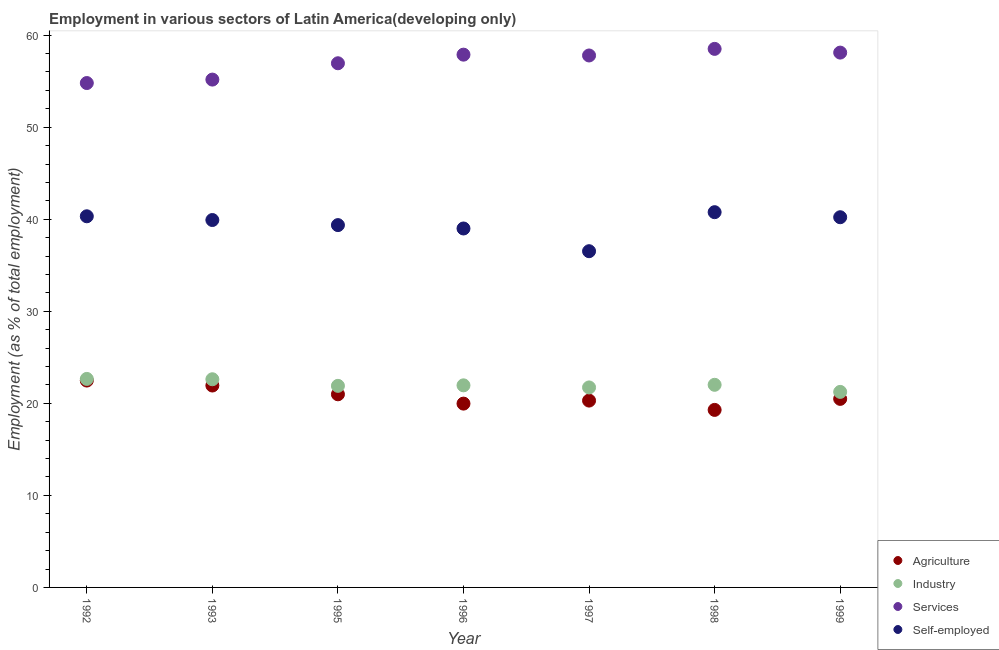Is the number of dotlines equal to the number of legend labels?
Make the answer very short. Yes. What is the percentage of self employed workers in 1995?
Keep it short and to the point. 39.36. Across all years, what is the maximum percentage of workers in services?
Keep it short and to the point. 58.51. Across all years, what is the minimum percentage of workers in industry?
Ensure brevity in your answer.  21.24. In which year was the percentage of workers in agriculture maximum?
Your answer should be compact. 1992. In which year was the percentage of workers in services minimum?
Your response must be concise. 1992. What is the total percentage of workers in industry in the graph?
Your answer should be very brief. 154.1. What is the difference between the percentage of workers in services in 1992 and that in 1996?
Make the answer very short. -3.08. What is the difference between the percentage of workers in industry in 1998 and the percentage of workers in agriculture in 1996?
Provide a succinct answer. 2.04. What is the average percentage of workers in industry per year?
Your response must be concise. 22.01. In the year 1993, what is the difference between the percentage of workers in services and percentage of workers in industry?
Your answer should be very brief. 32.56. In how many years, is the percentage of workers in agriculture greater than 40 %?
Give a very brief answer. 0. What is the ratio of the percentage of self employed workers in 1998 to that in 1999?
Offer a terse response. 1.01. Is the percentage of workers in industry in 1992 less than that in 1996?
Make the answer very short. No. Is the difference between the percentage of workers in industry in 1996 and 1997 greater than the difference between the percentage of workers in agriculture in 1996 and 1997?
Your answer should be compact. Yes. What is the difference between the highest and the second highest percentage of workers in agriculture?
Offer a terse response. 0.54. What is the difference between the highest and the lowest percentage of workers in agriculture?
Offer a terse response. 3.19. In how many years, is the percentage of workers in agriculture greater than the average percentage of workers in agriculture taken over all years?
Provide a short and direct response. 3. Is the sum of the percentage of workers in industry in 1992 and 1999 greater than the maximum percentage of workers in agriculture across all years?
Offer a terse response. Yes. Does the percentage of workers in industry monotonically increase over the years?
Your answer should be compact. No. Is the percentage of workers in agriculture strictly less than the percentage of self employed workers over the years?
Provide a short and direct response. Yes. How many years are there in the graph?
Provide a short and direct response. 7. What is the difference between two consecutive major ticks on the Y-axis?
Your answer should be very brief. 10. Are the values on the major ticks of Y-axis written in scientific E-notation?
Your answer should be compact. No. Does the graph contain any zero values?
Ensure brevity in your answer.  No. Where does the legend appear in the graph?
Your response must be concise. Bottom right. How are the legend labels stacked?
Your answer should be very brief. Vertical. What is the title of the graph?
Provide a short and direct response. Employment in various sectors of Latin America(developing only). What is the label or title of the Y-axis?
Ensure brevity in your answer.  Employment (as % of total employment). What is the Employment (as % of total employment) in Agriculture in 1992?
Offer a terse response. 22.47. What is the Employment (as % of total employment) in Industry in 1992?
Provide a short and direct response. 22.65. What is the Employment (as % of total employment) in Services in 1992?
Give a very brief answer. 54.8. What is the Employment (as % of total employment) of Self-employed in 1992?
Ensure brevity in your answer.  40.32. What is the Employment (as % of total employment) of Agriculture in 1993?
Make the answer very short. 21.94. What is the Employment (as % of total employment) of Industry in 1993?
Your answer should be compact. 22.61. What is the Employment (as % of total employment) of Services in 1993?
Ensure brevity in your answer.  55.17. What is the Employment (as % of total employment) of Self-employed in 1993?
Give a very brief answer. 39.91. What is the Employment (as % of total employment) in Agriculture in 1995?
Ensure brevity in your answer.  20.98. What is the Employment (as % of total employment) in Industry in 1995?
Your answer should be compact. 21.9. What is the Employment (as % of total employment) in Services in 1995?
Offer a terse response. 56.95. What is the Employment (as % of total employment) in Self-employed in 1995?
Your answer should be compact. 39.36. What is the Employment (as % of total employment) of Agriculture in 1996?
Offer a very short reply. 19.97. What is the Employment (as % of total employment) of Industry in 1996?
Keep it short and to the point. 21.95. What is the Employment (as % of total employment) of Services in 1996?
Make the answer very short. 57.88. What is the Employment (as % of total employment) in Self-employed in 1996?
Ensure brevity in your answer.  39. What is the Employment (as % of total employment) of Agriculture in 1997?
Your answer should be compact. 20.3. What is the Employment (as % of total employment) in Industry in 1997?
Offer a terse response. 21.73. What is the Employment (as % of total employment) of Services in 1997?
Your answer should be very brief. 57.79. What is the Employment (as % of total employment) in Self-employed in 1997?
Offer a terse response. 36.53. What is the Employment (as % of total employment) in Agriculture in 1998?
Your response must be concise. 19.29. What is the Employment (as % of total employment) of Industry in 1998?
Keep it short and to the point. 22.01. What is the Employment (as % of total employment) in Services in 1998?
Offer a very short reply. 58.51. What is the Employment (as % of total employment) in Self-employed in 1998?
Your answer should be very brief. 40.77. What is the Employment (as % of total employment) of Agriculture in 1999?
Provide a short and direct response. 20.48. What is the Employment (as % of total employment) of Industry in 1999?
Your response must be concise. 21.24. What is the Employment (as % of total employment) in Services in 1999?
Offer a very short reply. 58.1. What is the Employment (as % of total employment) in Self-employed in 1999?
Your response must be concise. 40.22. Across all years, what is the maximum Employment (as % of total employment) in Agriculture?
Provide a succinct answer. 22.47. Across all years, what is the maximum Employment (as % of total employment) in Industry?
Your response must be concise. 22.65. Across all years, what is the maximum Employment (as % of total employment) of Services?
Offer a terse response. 58.51. Across all years, what is the maximum Employment (as % of total employment) in Self-employed?
Ensure brevity in your answer.  40.77. Across all years, what is the minimum Employment (as % of total employment) in Agriculture?
Offer a very short reply. 19.29. Across all years, what is the minimum Employment (as % of total employment) of Industry?
Keep it short and to the point. 21.24. Across all years, what is the minimum Employment (as % of total employment) of Services?
Your answer should be very brief. 54.8. Across all years, what is the minimum Employment (as % of total employment) of Self-employed?
Offer a very short reply. 36.53. What is the total Employment (as % of total employment) of Agriculture in the graph?
Your response must be concise. 145.43. What is the total Employment (as % of total employment) in Industry in the graph?
Offer a terse response. 154.1. What is the total Employment (as % of total employment) in Services in the graph?
Provide a succinct answer. 399.19. What is the total Employment (as % of total employment) of Self-employed in the graph?
Offer a very short reply. 276.11. What is the difference between the Employment (as % of total employment) in Agriculture in 1992 and that in 1993?
Provide a succinct answer. 0.54. What is the difference between the Employment (as % of total employment) of Industry in 1992 and that in 1993?
Give a very brief answer. 0.04. What is the difference between the Employment (as % of total employment) of Services in 1992 and that in 1993?
Give a very brief answer. -0.38. What is the difference between the Employment (as % of total employment) of Self-employed in 1992 and that in 1993?
Provide a short and direct response. 0.41. What is the difference between the Employment (as % of total employment) of Agriculture in 1992 and that in 1995?
Offer a very short reply. 1.49. What is the difference between the Employment (as % of total employment) in Industry in 1992 and that in 1995?
Offer a terse response. 0.75. What is the difference between the Employment (as % of total employment) in Services in 1992 and that in 1995?
Keep it short and to the point. -2.15. What is the difference between the Employment (as % of total employment) in Self-employed in 1992 and that in 1995?
Ensure brevity in your answer.  0.96. What is the difference between the Employment (as % of total employment) in Agriculture in 1992 and that in 1996?
Make the answer very short. 2.5. What is the difference between the Employment (as % of total employment) in Industry in 1992 and that in 1996?
Provide a succinct answer. 0.7. What is the difference between the Employment (as % of total employment) of Services in 1992 and that in 1996?
Your answer should be very brief. -3.08. What is the difference between the Employment (as % of total employment) in Self-employed in 1992 and that in 1996?
Provide a short and direct response. 1.33. What is the difference between the Employment (as % of total employment) in Agriculture in 1992 and that in 1997?
Your answer should be very brief. 2.18. What is the difference between the Employment (as % of total employment) of Industry in 1992 and that in 1997?
Provide a short and direct response. 0.93. What is the difference between the Employment (as % of total employment) in Services in 1992 and that in 1997?
Your answer should be compact. -2.99. What is the difference between the Employment (as % of total employment) of Self-employed in 1992 and that in 1997?
Ensure brevity in your answer.  3.79. What is the difference between the Employment (as % of total employment) in Agriculture in 1992 and that in 1998?
Provide a short and direct response. 3.19. What is the difference between the Employment (as % of total employment) of Industry in 1992 and that in 1998?
Provide a short and direct response. 0.64. What is the difference between the Employment (as % of total employment) of Services in 1992 and that in 1998?
Your answer should be compact. -3.71. What is the difference between the Employment (as % of total employment) of Self-employed in 1992 and that in 1998?
Ensure brevity in your answer.  -0.45. What is the difference between the Employment (as % of total employment) of Agriculture in 1992 and that in 1999?
Give a very brief answer. 1.99. What is the difference between the Employment (as % of total employment) in Industry in 1992 and that in 1999?
Make the answer very short. 1.41. What is the difference between the Employment (as % of total employment) in Services in 1992 and that in 1999?
Your answer should be very brief. -3.31. What is the difference between the Employment (as % of total employment) in Self-employed in 1992 and that in 1999?
Your answer should be compact. 0.1. What is the difference between the Employment (as % of total employment) of Agriculture in 1993 and that in 1995?
Keep it short and to the point. 0.95. What is the difference between the Employment (as % of total employment) of Industry in 1993 and that in 1995?
Provide a short and direct response. 0.72. What is the difference between the Employment (as % of total employment) in Services in 1993 and that in 1995?
Keep it short and to the point. -1.77. What is the difference between the Employment (as % of total employment) of Self-employed in 1993 and that in 1995?
Offer a very short reply. 0.55. What is the difference between the Employment (as % of total employment) in Agriculture in 1993 and that in 1996?
Your answer should be very brief. 1.97. What is the difference between the Employment (as % of total employment) of Industry in 1993 and that in 1996?
Your response must be concise. 0.66. What is the difference between the Employment (as % of total employment) in Services in 1993 and that in 1996?
Make the answer very short. -2.71. What is the difference between the Employment (as % of total employment) of Self-employed in 1993 and that in 1996?
Your answer should be compact. 0.92. What is the difference between the Employment (as % of total employment) in Agriculture in 1993 and that in 1997?
Your answer should be compact. 1.64. What is the difference between the Employment (as % of total employment) of Industry in 1993 and that in 1997?
Keep it short and to the point. 0.89. What is the difference between the Employment (as % of total employment) in Services in 1993 and that in 1997?
Your response must be concise. -2.62. What is the difference between the Employment (as % of total employment) in Self-employed in 1993 and that in 1997?
Give a very brief answer. 3.39. What is the difference between the Employment (as % of total employment) in Agriculture in 1993 and that in 1998?
Offer a terse response. 2.65. What is the difference between the Employment (as % of total employment) in Industry in 1993 and that in 1998?
Your answer should be very brief. 0.6. What is the difference between the Employment (as % of total employment) of Services in 1993 and that in 1998?
Your answer should be very brief. -3.34. What is the difference between the Employment (as % of total employment) of Self-employed in 1993 and that in 1998?
Provide a succinct answer. -0.85. What is the difference between the Employment (as % of total employment) in Agriculture in 1993 and that in 1999?
Make the answer very short. 1.45. What is the difference between the Employment (as % of total employment) in Industry in 1993 and that in 1999?
Your response must be concise. 1.37. What is the difference between the Employment (as % of total employment) in Services in 1993 and that in 1999?
Your answer should be compact. -2.93. What is the difference between the Employment (as % of total employment) of Self-employed in 1993 and that in 1999?
Your response must be concise. -0.3. What is the difference between the Employment (as % of total employment) in Agriculture in 1995 and that in 1996?
Your answer should be very brief. 1.01. What is the difference between the Employment (as % of total employment) in Industry in 1995 and that in 1996?
Ensure brevity in your answer.  -0.06. What is the difference between the Employment (as % of total employment) of Services in 1995 and that in 1996?
Offer a very short reply. -0.94. What is the difference between the Employment (as % of total employment) in Self-employed in 1995 and that in 1996?
Provide a short and direct response. 0.37. What is the difference between the Employment (as % of total employment) in Agriculture in 1995 and that in 1997?
Offer a terse response. 0.68. What is the difference between the Employment (as % of total employment) of Industry in 1995 and that in 1997?
Make the answer very short. 0.17. What is the difference between the Employment (as % of total employment) in Services in 1995 and that in 1997?
Your response must be concise. -0.85. What is the difference between the Employment (as % of total employment) of Self-employed in 1995 and that in 1997?
Offer a very short reply. 2.84. What is the difference between the Employment (as % of total employment) in Agriculture in 1995 and that in 1998?
Provide a succinct answer. 1.69. What is the difference between the Employment (as % of total employment) of Industry in 1995 and that in 1998?
Keep it short and to the point. -0.11. What is the difference between the Employment (as % of total employment) of Services in 1995 and that in 1998?
Your response must be concise. -1.56. What is the difference between the Employment (as % of total employment) of Self-employed in 1995 and that in 1998?
Your response must be concise. -1.4. What is the difference between the Employment (as % of total employment) of Agriculture in 1995 and that in 1999?
Your answer should be very brief. 0.5. What is the difference between the Employment (as % of total employment) of Industry in 1995 and that in 1999?
Provide a succinct answer. 0.66. What is the difference between the Employment (as % of total employment) of Services in 1995 and that in 1999?
Keep it short and to the point. -1.16. What is the difference between the Employment (as % of total employment) in Self-employed in 1995 and that in 1999?
Make the answer very short. -0.86. What is the difference between the Employment (as % of total employment) of Agriculture in 1996 and that in 1997?
Your answer should be very brief. -0.33. What is the difference between the Employment (as % of total employment) in Industry in 1996 and that in 1997?
Your answer should be very brief. 0.23. What is the difference between the Employment (as % of total employment) of Services in 1996 and that in 1997?
Provide a short and direct response. 0.09. What is the difference between the Employment (as % of total employment) in Self-employed in 1996 and that in 1997?
Make the answer very short. 2.47. What is the difference between the Employment (as % of total employment) in Agriculture in 1996 and that in 1998?
Your answer should be very brief. 0.68. What is the difference between the Employment (as % of total employment) in Industry in 1996 and that in 1998?
Your answer should be compact. -0.06. What is the difference between the Employment (as % of total employment) of Services in 1996 and that in 1998?
Provide a succinct answer. -0.63. What is the difference between the Employment (as % of total employment) in Self-employed in 1996 and that in 1998?
Offer a very short reply. -1.77. What is the difference between the Employment (as % of total employment) of Agriculture in 1996 and that in 1999?
Ensure brevity in your answer.  -0.51. What is the difference between the Employment (as % of total employment) of Industry in 1996 and that in 1999?
Provide a short and direct response. 0.71. What is the difference between the Employment (as % of total employment) in Services in 1996 and that in 1999?
Offer a terse response. -0.22. What is the difference between the Employment (as % of total employment) of Self-employed in 1996 and that in 1999?
Provide a succinct answer. -1.22. What is the difference between the Employment (as % of total employment) in Agriculture in 1997 and that in 1998?
Your answer should be compact. 1.01. What is the difference between the Employment (as % of total employment) in Industry in 1997 and that in 1998?
Provide a short and direct response. -0.29. What is the difference between the Employment (as % of total employment) of Services in 1997 and that in 1998?
Your response must be concise. -0.72. What is the difference between the Employment (as % of total employment) in Self-employed in 1997 and that in 1998?
Provide a short and direct response. -4.24. What is the difference between the Employment (as % of total employment) of Agriculture in 1997 and that in 1999?
Offer a very short reply. -0.19. What is the difference between the Employment (as % of total employment) of Industry in 1997 and that in 1999?
Keep it short and to the point. 0.48. What is the difference between the Employment (as % of total employment) of Services in 1997 and that in 1999?
Your answer should be compact. -0.31. What is the difference between the Employment (as % of total employment) in Self-employed in 1997 and that in 1999?
Ensure brevity in your answer.  -3.69. What is the difference between the Employment (as % of total employment) of Agriculture in 1998 and that in 1999?
Provide a short and direct response. -1.2. What is the difference between the Employment (as % of total employment) in Industry in 1998 and that in 1999?
Ensure brevity in your answer.  0.77. What is the difference between the Employment (as % of total employment) in Services in 1998 and that in 1999?
Keep it short and to the point. 0.4. What is the difference between the Employment (as % of total employment) of Self-employed in 1998 and that in 1999?
Give a very brief answer. 0.55. What is the difference between the Employment (as % of total employment) of Agriculture in 1992 and the Employment (as % of total employment) of Industry in 1993?
Your answer should be very brief. -0.14. What is the difference between the Employment (as % of total employment) in Agriculture in 1992 and the Employment (as % of total employment) in Services in 1993?
Provide a succinct answer. -32.7. What is the difference between the Employment (as % of total employment) in Agriculture in 1992 and the Employment (as % of total employment) in Self-employed in 1993?
Your response must be concise. -17.44. What is the difference between the Employment (as % of total employment) of Industry in 1992 and the Employment (as % of total employment) of Services in 1993?
Ensure brevity in your answer.  -32.52. What is the difference between the Employment (as % of total employment) of Industry in 1992 and the Employment (as % of total employment) of Self-employed in 1993?
Ensure brevity in your answer.  -17.26. What is the difference between the Employment (as % of total employment) in Services in 1992 and the Employment (as % of total employment) in Self-employed in 1993?
Your answer should be compact. 14.88. What is the difference between the Employment (as % of total employment) in Agriculture in 1992 and the Employment (as % of total employment) in Industry in 1995?
Make the answer very short. 0.57. What is the difference between the Employment (as % of total employment) of Agriculture in 1992 and the Employment (as % of total employment) of Services in 1995?
Your response must be concise. -34.47. What is the difference between the Employment (as % of total employment) in Agriculture in 1992 and the Employment (as % of total employment) in Self-employed in 1995?
Give a very brief answer. -16.89. What is the difference between the Employment (as % of total employment) in Industry in 1992 and the Employment (as % of total employment) in Services in 1995?
Offer a very short reply. -34.29. What is the difference between the Employment (as % of total employment) in Industry in 1992 and the Employment (as % of total employment) in Self-employed in 1995?
Offer a terse response. -16.71. What is the difference between the Employment (as % of total employment) in Services in 1992 and the Employment (as % of total employment) in Self-employed in 1995?
Provide a succinct answer. 15.43. What is the difference between the Employment (as % of total employment) in Agriculture in 1992 and the Employment (as % of total employment) in Industry in 1996?
Give a very brief answer. 0.52. What is the difference between the Employment (as % of total employment) in Agriculture in 1992 and the Employment (as % of total employment) in Services in 1996?
Keep it short and to the point. -35.41. What is the difference between the Employment (as % of total employment) in Agriculture in 1992 and the Employment (as % of total employment) in Self-employed in 1996?
Offer a very short reply. -16.52. What is the difference between the Employment (as % of total employment) of Industry in 1992 and the Employment (as % of total employment) of Services in 1996?
Provide a succinct answer. -35.23. What is the difference between the Employment (as % of total employment) of Industry in 1992 and the Employment (as % of total employment) of Self-employed in 1996?
Ensure brevity in your answer.  -16.34. What is the difference between the Employment (as % of total employment) in Services in 1992 and the Employment (as % of total employment) in Self-employed in 1996?
Give a very brief answer. 15.8. What is the difference between the Employment (as % of total employment) of Agriculture in 1992 and the Employment (as % of total employment) of Industry in 1997?
Give a very brief answer. 0.75. What is the difference between the Employment (as % of total employment) in Agriculture in 1992 and the Employment (as % of total employment) in Services in 1997?
Your response must be concise. -35.32. What is the difference between the Employment (as % of total employment) of Agriculture in 1992 and the Employment (as % of total employment) of Self-employed in 1997?
Your answer should be very brief. -14.05. What is the difference between the Employment (as % of total employment) of Industry in 1992 and the Employment (as % of total employment) of Services in 1997?
Give a very brief answer. -35.14. What is the difference between the Employment (as % of total employment) of Industry in 1992 and the Employment (as % of total employment) of Self-employed in 1997?
Your answer should be compact. -13.88. What is the difference between the Employment (as % of total employment) of Services in 1992 and the Employment (as % of total employment) of Self-employed in 1997?
Your response must be concise. 18.27. What is the difference between the Employment (as % of total employment) of Agriculture in 1992 and the Employment (as % of total employment) of Industry in 1998?
Give a very brief answer. 0.46. What is the difference between the Employment (as % of total employment) of Agriculture in 1992 and the Employment (as % of total employment) of Services in 1998?
Ensure brevity in your answer.  -36.03. What is the difference between the Employment (as % of total employment) of Agriculture in 1992 and the Employment (as % of total employment) of Self-employed in 1998?
Make the answer very short. -18.29. What is the difference between the Employment (as % of total employment) of Industry in 1992 and the Employment (as % of total employment) of Services in 1998?
Give a very brief answer. -35.86. What is the difference between the Employment (as % of total employment) of Industry in 1992 and the Employment (as % of total employment) of Self-employed in 1998?
Give a very brief answer. -18.11. What is the difference between the Employment (as % of total employment) of Services in 1992 and the Employment (as % of total employment) of Self-employed in 1998?
Make the answer very short. 14.03. What is the difference between the Employment (as % of total employment) in Agriculture in 1992 and the Employment (as % of total employment) in Industry in 1999?
Keep it short and to the point. 1.23. What is the difference between the Employment (as % of total employment) in Agriculture in 1992 and the Employment (as % of total employment) in Services in 1999?
Provide a succinct answer. -35.63. What is the difference between the Employment (as % of total employment) in Agriculture in 1992 and the Employment (as % of total employment) in Self-employed in 1999?
Make the answer very short. -17.74. What is the difference between the Employment (as % of total employment) in Industry in 1992 and the Employment (as % of total employment) in Services in 1999?
Provide a short and direct response. -35.45. What is the difference between the Employment (as % of total employment) in Industry in 1992 and the Employment (as % of total employment) in Self-employed in 1999?
Make the answer very short. -17.57. What is the difference between the Employment (as % of total employment) of Services in 1992 and the Employment (as % of total employment) of Self-employed in 1999?
Offer a terse response. 14.58. What is the difference between the Employment (as % of total employment) of Agriculture in 1993 and the Employment (as % of total employment) of Industry in 1995?
Offer a terse response. 0.04. What is the difference between the Employment (as % of total employment) in Agriculture in 1993 and the Employment (as % of total employment) in Services in 1995?
Give a very brief answer. -35.01. What is the difference between the Employment (as % of total employment) of Agriculture in 1993 and the Employment (as % of total employment) of Self-employed in 1995?
Provide a short and direct response. -17.43. What is the difference between the Employment (as % of total employment) of Industry in 1993 and the Employment (as % of total employment) of Services in 1995?
Keep it short and to the point. -34.33. What is the difference between the Employment (as % of total employment) of Industry in 1993 and the Employment (as % of total employment) of Self-employed in 1995?
Give a very brief answer. -16.75. What is the difference between the Employment (as % of total employment) in Services in 1993 and the Employment (as % of total employment) in Self-employed in 1995?
Keep it short and to the point. 15.81. What is the difference between the Employment (as % of total employment) in Agriculture in 1993 and the Employment (as % of total employment) in Industry in 1996?
Provide a short and direct response. -0.02. What is the difference between the Employment (as % of total employment) of Agriculture in 1993 and the Employment (as % of total employment) of Services in 1996?
Provide a short and direct response. -35.95. What is the difference between the Employment (as % of total employment) of Agriculture in 1993 and the Employment (as % of total employment) of Self-employed in 1996?
Offer a terse response. -17.06. What is the difference between the Employment (as % of total employment) of Industry in 1993 and the Employment (as % of total employment) of Services in 1996?
Keep it short and to the point. -35.27. What is the difference between the Employment (as % of total employment) of Industry in 1993 and the Employment (as % of total employment) of Self-employed in 1996?
Your response must be concise. -16.38. What is the difference between the Employment (as % of total employment) of Services in 1993 and the Employment (as % of total employment) of Self-employed in 1996?
Your answer should be compact. 16.18. What is the difference between the Employment (as % of total employment) in Agriculture in 1993 and the Employment (as % of total employment) in Industry in 1997?
Provide a succinct answer. 0.21. What is the difference between the Employment (as % of total employment) in Agriculture in 1993 and the Employment (as % of total employment) in Services in 1997?
Ensure brevity in your answer.  -35.86. What is the difference between the Employment (as % of total employment) in Agriculture in 1993 and the Employment (as % of total employment) in Self-employed in 1997?
Your answer should be compact. -14.59. What is the difference between the Employment (as % of total employment) of Industry in 1993 and the Employment (as % of total employment) of Services in 1997?
Offer a very short reply. -35.18. What is the difference between the Employment (as % of total employment) of Industry in 1993 and the Employment (as % of total employment) of Self-employed in 1997?
Provide a succinct answer. -13.91. What is the difference between the Employment (as % of total employment) in Services in 1993 and the Employment (as % of total employment) in Self-employed in 1997?
Offer a very short reply. 18.64. What is the difference between the Employment (as % of total employment) in Agriculture in 1993 and the Employment (as % of total employment) in Industry in 1998?
Provide a short and direct response. -0.08. What is the difference between the Employment (as % of total employment) in Agriculture in 1993 and the Employment (as % of total employment) in Services in 1998?
Give a very brief answer. -36.57. What is the difference between the Employment (as % of total employment) in Agriculture in 1993 and the Employment (as % of total employment) in Self-employed in 1998?
Your answer should be compact. -18.83. What is the difference between the Employment (as % of total employment) of Industry in 1993 and the Employment (as % of total employment) of Services in 1998?
Offer a very short reply. -35.89. What is the difference between the Employment (as % of total employment) in Industry in 1993 and the Employment (as % of total employment) in Self-employed in 1998?
Your answer should be compact. -18.15. What is the difference between the Employment (as % of total employment) of Services in 1993 and the Employment (as % of total employment) of Self-employed in 1998?
Ensure brevity in your answer.  14.4. What is the difference between the Employment (as % of total employment) in Agriculture in 1993 and the Employment (as % of total employment) in Industry in 1999?
Offer a very short reply. 0.69. What is the difference between the Employment (as % of total employment) in Agriculture in 1993 and the Employment (as % of total employment) in Services in 1999?
Provide a short and direct response. -36.17. What is the difference between the Employment (as % of total employment) in Agriculture in 1993 and the Employment (as % of total employment) in Self-employed in 1999?
Give a very brief answer. -18.28. What is the difference between the Employment (as % of total employment) in Industry in 1993 and the Employment (as % of total employment) in Services in 1999?
Provide a succinct answer. -35.49. What is the difference between the Employment (as % of total employment) in Industry in 1993 and the Employment (as % of total employment) in Self-employed in 1999?
Provide a short and direct response. -17.6. What is the difference between the Employment (as % of total employment) of Services in 1993 and the Employment (as % of total employment) of Self-employed in 1999?
Provide a short and direct response. 14.95. What is the difference between the Employment (as % of total employment) in Agriculture in 1995 and the Employment (as % of total employment) in Industry in 1996?
Keep it short and to the point. -0.97. What is the difference between the Employment (as % of total employment) in Agriculture in 1995 and the Employment (as % of total employment) in Services in 1996?
Ensure brevity in your answer.  -36.9. What is the difference between the Employment (as % of total employment) in Agriculture in 1995 and the Employment (as % of total employment) in Self-employed in 1996?
Ensure brevity in your answer.  -18.01. What is the difference between the Employment (as % of total employment) of Industry in 1995 and the Employment (as % of total employment) of Services in 1996?
Offer a terse response. -35.98. What is the difference between the Employment (as % of total employment) in Industry in 1995 and the Employment (as % of total employment) in Self-employed in 1996?
Provide a short and direct response. -17.1. What is the difference between the Employment (as % of total employment) of Services in 1995 and the Employment (as % of total employment) of Self-employed in 1996?
Ensure brevity in your answer.  17.95. What is the difference between the Employment (as % of total employment) in Agriculture in 1995 and the Employment (as % of total employment) in Industry in 1997?
Your answer should be very brief. -0.75. What is the difference between the Employment (as % of total employment) in Agriculture in 1995 and the Employment (as % of total employment) in Services in 1997?
Keep it short and to the point. -36.81. What is the difference between the Employment (as % of total employment) in Agriculture in 1995 and the Employment (as % of total employment) in Self-employed in 1997?
Your answer should be very brief. -15.55. What is the difference between the Employment (as % of total employment) in Industry in 1995 and the Employment (as % of total employment) in Services in 1997?
Keep it short and to the point. -35.89. What is the difference between the Employment (as % of total employment) in Industry in 1995 and the Employment (as % of total employment) in Self-employed in 1997?
Provide a short and direct response. -14.63. What is the difference between the Employment (as % of total employment) of Services in 1995 and the Employment (as % of total employment) of Self-employed in 1997?
Your answer should be very brief. 20.42. What is the difference between the Employment (as % of total employment) in Agriculture in 1995 and the Employment (as % of total employment) in Industry in 1998?
Provide a succinct answer. -1.03. What is the difference between the Employment (as % of total employment) of Agriculture in 1995 and the Employment (as % of total employment) of Services in 1998?
Ensure brevity in your answer.  -37.53. What is the difference between the Employment (as % of total employment) of Agriculture in 1995 and the Employment (as % of total employment) of Self-employed in 1998?
Your response must be concise. -19.79. What is the difference between the Employment (as % of total employment) in Industry in 1995 and the Employment (as % of total employment) in Services in 1998?
Give a very brief answer. -36.61. What is the difference between the Employment (as % of total employment) of Industry in 1995 and the Employment (as % of total employment) of Self-employed in 1998?
Offer a terse response. -18.87. What is the difference between the Employment (as % of total employment) in Services in 1995 and the Employment (as % of total employment) in Self-employed in 1998?
Your answer should be compact. 16.18. What is the difference between the Employment (as % of total employment) in Agriculture in 1995 and the Employment (as % of total employment) in Industry in 1999?
Ensure brevity in your answer.  -0.26. What is the difference between the Employment (as % of total employment) of Agriculture in 1995 and the Employment (as % of total employment) of Services in 1999?
Give a very brief answer. -37.12. What is the difference between the Employment (as % of total employment) of Agriculture in 1995 and the Employment (as % of total employment) of Self-employed in 1999?
Provide a short and direct response. -19.24. What is the difference between the Employment (as % of total employment) of Industry in 1995 and the Employment (as % of total employment) of Services in 1999?
Ensure brevity in your answer.  -36.2. What is the difference between the Employment (as % of total employment) of Industry in 1995 and the Employment (as % of total employment) of Self-employed in 1999?
Offer a very short reply. -18.32. What is the difference between the Employment (as % of total employment) of Services in 1995 and the Employment (as % of total employment) of Self-employed in 1999?
Ensure brevity in your answer.  16.73. What is the difference between the Employment (as % of total employment) of Agriculture in 1996 and the Employment (as % of total employment) of Industry in 1997?
Your answer should be very brief. -1.76. What is the difference between the Employment (as % of total employment) of Agriculture in 1996 and the Employment (as % of total employment) of Services in 1997?
Your answer should be compact. -37.82. What is the difference between the Employment (as % of total employment) in Agriculture in 1996 and the Employment (as % of total employment) in Self-employed in 1997?
Make the answer very short. -16.56. What is the difference between the Employment (as % of total employment) in Industry in 1996 and the Employment (as % of total employment) in Services in 1997?
Your answer should be compact. -35.84. What is the difference between the Employment (as % of total employment) in Industry in 1996 and the Employment (as % of total employment) in Self-employed in 1997?
Your answer should be compact. -14.57. What is the difference between the Employment (as % of total employment) in Services in 1996 and the Employment (as % of total employment) in Self-employed in 1997?
Ensure brevity in your answer.  21.35. What is the difference between the Employment (as % of total employment) of Agriculture in 1996 and the Employment (as % of total employment) of Industry in 1998?
Ensure brevity in your answer.  -2.04. What is the difference between the Employment (as % of total employment) in Agriculture in 1996 and the Employment (as % of total employment) in Services in 1998?
Provide a succinct answer. -38.54. What is the difference between the Employment (as % of total employment) of Agriculture in 1996 and the Employment (as % of total employment) of Self-employed in 1998?
Your answer should be very brief. -20.8. What is the difference between the Employment (as % of total employment) of Industry in 1996 and the Employment (as % of total employment) of Services in 1998?
Provide a short and direct response. -36.55. What is the difference between the Employment (as % of total employment) in Industry in 1996 and the Employment (as % of total employment) in Self-employed in 1998?
Keep it short and to the point. -18.81. What is the difference between the Employment (as % of total employment) of Services in 1996 and the Employment (as % of total employment) of Self-employed in 1998?
Your response must be concise. 17.11. What is the difference between the Employment (as % of total employment) of Agriculture in 1996 and the Employment (as % of total employment) of Industry in 1999?
Give a very brief answer. -1.27. What is the difference between the Employment (as % of total employment) in Agriculture in 1996 and the Employment (as % of total employment) in Services in 1999?
Provide a succinct answer. -38.13. What is the difference between the Employment (as % of total employment) of Agriculture in 1996 and the Employment (as % of total employment) of Self-employed in 1999?
Your answer should be very brief. -20.25. What is the difference between the Employment (as % of total employment) in Industry in 1996 and the Employment (as % of total employment) in Services in 1999?
Your answer should be very brief. -36.15. What is the difference between the Employment (as % of total employment) of Industry in 1996 and the Employment (as % of total employment) of Self-employed in 1999?
Make the answer very short. -18.26. What is the difference between the Employment (as % of total employment) of Services in 1996 and the Employment (as % of total employment) of Self-employed in 1999?
Provide a succinct answer. 17.66. What is the difference between the Employment (as % of total employment) in Agriculture in 1997 and the Employment (as % of total employment) in Industry in 1998?
Keep it short and to the point. -1.71. What is the difference between the Employment (as % of total employment) in Agriculture in 1997 and the Employment (as % of total employment) in Services in 1998?
Ensure brevity in your answer.  -38.21. What is the difference between the Employment (as % of total employment) in Agriculture in 1997 and the Employment (as % of total employment) in Self-employed in 1998?
Give a very brief answer. -20.47. What is the difference between the Employment (as % of total employment) in Industry in 1997 and the Employment (as % of total employment) in Services in 1998?
Make the answer very short. -36.78. What is the difference between the Employment (as % of total employment) of Industry in 1997 and the Employment (as % of total employment) of Self-employed in 1998?
Offer a terse response. -19.04. What is the difference between the Employment (as % of total employment) of Services in 1997 and the Employment (as % of total employment) of Self-employed in 1998?
Offer a very short reply. 17.02. What is the difference between the Employment (as % of total employment) of Agriculture in 1997 and the Employment (as % of total employment) of Industry in 1999?
Offer a very short reply. -0.94. What is the difference between the Employment (as % of total employment) of Agriculture in 1997 and the Employment (as % of total employment) of Services in 1999?
Ensure brevity in your answer.  -37.81. What is the difference between the Employment (as % of total employment) of Agriculture in 1997 and the Employment (as % of total employment) of Self-employed in 1999?
Your answer should be very brief. -19.92. What is the difference between the Employment (as % of total employment) of Industry in 1997 and the Employment (as % of total employment) of Services in 1999?
Your response must be concise. -36.38. What is the difference between the Employment (as % of total employment) of Industry in 1997 and the Employment (as % of total employment) of Self-employed in 1999?
Your response must be concise. -18.49. What is the difference between the Employment (as % of total employment) in Services in 1997 and the Employment (as % of total employment) in Self-employed in 1999?
Your answer should be very brief. 17.57. What is the difference between the Employment (as % of total employment) of Agriculture in 1998 and the Employment (as % of total employment) of Industry in 1999?
Your answer should be compact. -1.96. What is the difference between the Employment (as % of total employment) in Agriculture in 1998 and the Employment (as % of total employment) in Services in 1999?
Provide a short and direct response. -38.82. What is the difference between the Employment (as % of total employment) in Agriculture in 1998 and the Employment (as % of total employment) in Self-employed in 1999?
Offer a terse response. -20.93. What is the difference between the Employment (as % of total employment) of Industry in 1998 and the Employment (as % of total employment) of Services in 1999?
Ensure brevity in your answer.  -36.09. What is the difference between the Employment (as % of total employment) of Industry in 1998 and the Employment (as % of total employment) of Self-employed in 1999?
Keep it short and to the point. -18.21. What is the difference between the Employment (as % of total employment) in Services in 1998 and the Employment (as % of total employment) in Self-employed in 1999?
Keep it short and to the point. 18.29. What is the average Employment (as % of total employment) in Agriculture per year?
Give a very brief answer. 20.78. What is the average Employment (as % of total employment) of Industry per year?
Your response must be concise. 22.01. What is the average Employment (as % of total employment) in Services per year?
Offer a terse response. 57.03. What is the average Employment (as % of total employment) of Self-employed per year?
Your response must be concise. 39.44. In the year 1992, what is the difference between the Employment (as % of total employment) of Agriculture and Employment (as % of total employment) of Industry?
Give a very brief answer. -0.18. In the year 1992, what is the difference between the Employment (as % of total employment) of Agriculture and Employment (as % of total employment) of Services?
Make the answer very short. -32.32. In the year 1992, what is the difference between the Employment (as % of total employment) of Agriculture and Employment (as % of total employment) of Self-employed?
Provide a short and direct response. -17.85. In the year 1992, what is the difference between the Employment (as % of total employment) of Industry and Employment (as % of total employment) of Services?
Provide a succinct answer. -32.14. In the year 1992, what is the difference between the Employment (as % of total employment) in Industry and Employment (as % of total employment) in Self-employed?
Provide a short and direct response. -17.67. In the year 1992, what is the difference between the Employment (as % of total employment) in Services and Employment (as % of total employment) in Self-employed?
Provide a succinct answer. 14.48. In the year 1993, what is the difference between the Employment (as % of total employment) in Agriculture and Employment (as % of total employment) in Industry?
Offer a very short reply. -0.68. In the year 1993, what is the difference between the Employment (as % of total employment) in Agriculture and Employment (as % of total employment) in Services?
Keep it short and to the point. -33.24. In the year 1993, what is the difference between the Employment (as % of total employment) in Agriculture and Employment (as % of total employment) in Self-employed?
Offer a very short reply. -17.98. In the year 1993, what is the difference between the Employment (as % of total employment) in Industry and Employment (as % of total employment) in Services?
Your response must be concise. -32.56. In the year 1993, what is the difference between the Employment (as % of total employment) in Industry and Employment (as % of total employment) in Self-employed?
Your response must be concise. -17.3. In the year 1993, what is the difference between the Employment (as % of total employment) in Services and Employment (as % of total employment) in Self-employed?
Provide a succinct answer. 15.26. In the year 1995, what is the difference between the Employment (as % of total employment) of Agriculture and Employment (as % of total employment) of Industry?
Provide a short and direct response. -0.92. In the year 1995, what is the difference between the Employment (as % of total employment) of Agriculture and Employment (as % of total employment) of Services?
Make the answer very short. -35.96. In the year 1995, what is the difference between the Employment (as % of total employment) in Agriculture and Employment (as % of total employment) in Self-employed?
Offer a very short reply. -18.38. In the year 1995, what is the difference between the Employment (as % of total employment) of Industry and Employment (as % of total employment) of Services?
Make the answer very short. -35.05. In the year 1995, what is the difference between the Employment (as % of total employment) of Industry and Employment (as % of total employment) of Self-employed?
Make the answer very short. -17.46. In the year 1995, what is the difference between the Employment (as % of total employment) in Services and Employment (as % of total employment) in Self-employed?
Provide a short and direct response. 17.58. In the year 1996, what is the difference between the Employment (as % of total employment) in Agriculture and Employment (as % of total employment) in Industry?
Your answer should be very brief. -1.99. In the year 1996, what is the difference between the Employment (as % of total employment) in Agriculture and Employment (as % of total employment) in Services?
Your answer should be very brief. -37.91. In the year 1996, what is the difference between the Employment (as % of total employment) of Agriculture and Employment (as % of total employment) of Self-employed?
Give a very brief answer. -19.03. In the year 1996, what is the difference between the Employment (as % of total employment) of Industry and Employment (as % of total employment) of Services?
Offer a terse response. -35.93. In the year 1996, what is the difference between the Employment (as % of total employment) of Industry and Employment (as % of total employment) of Self-employed?
Your answer should be compact. -17.04. In the year 1996, what is the difference between the Employment (as % of total employment) in Services and Employment (as % of total employment) in Self-employed?
Keep it short and to the point. 18.89. In the year 1997, what is the difference between the Employment (as % of total employment) of Agriculture and Employment (as % of total employment) of Industry?
Offer a very short reply. -1.43. In the year 1997, what is the difference between the Employment (as % of total employment) of Agriculture and Employment (as % of total employment) of Services?
Provide a succinct answer. -37.49. In the year 1997, what is the difference between the Employment (as % of total employment) in Agriculture and Employment (as % of total employment) in Self-employed?
Your answer should be compact. -16.23. In the year 1997, what is the difference between the Employment (as % of total employment) in Industry and Employment (as % of total employment) in Services?
Ensure brevity in your answer.  -36.06. In the year 1997, what is the difference between the Employment (as % of total employment) in Industry and Employment (as % of total employment) in Self-employed?
Keep it short and to the point. -14.8. In the year 1997, what is the difference between the Employment (as % of total employment) in Services and Employment (as % of total employment) in Self-employed?
Make the answer very short. 21.26. In the year 1998, what is the difference between the Employment (as % of total employment) of Agriculture and Employment (as % of total employment) of Industry?
Offer a very short reply. -2.73. In the year 1998, what is the difference between the Employment (as % of total employment) in Agriculture and Employment (as % of total employment) in Services?
Ensure brevity in your answer.  -39.22. In the year 1998, what is the difference between the Employment (as % of total employment) of Agriculture and Employment (as % of total employment) of Self-employed?
Give a very brief answer. -21.48. In the year 1998, what is the difference between the Employment (as % of total employment) of Industry and Employment (as % of total employment) of Services?
Ensure brevity in your answer.  -36.5. In the year 1998, what is the difference between the Employment (as % of total employment) of Industry and Employment (as % of total employment) of Self-employed?
Offer a terse response. -18.75. In the year 1998, what is the difference between the Employment (as % of total employment) of Services and Employment (as % of total employment) of Self-employed?
Give a very brief answer. 17.74. In the year 1999, what is the difference between the Employment (as % of total employment) in Agriculture and Employment (as % of total employment) in Industry?
Your answer should be very brief. -0.76. In the year 1999, what is the difference between the Employment (as % of total employment) in Agriculture and Employment (as % of total employment) in Services?
Your answer should be compact. -37.62. In the year 1999, what is the difference between the Employment (as % of total employment) of Agriculture and Employment (as % of total employment) of Self-employed?
Offer a very short reply. -19.74. In the year 1999, what is the difference between the Employment (as % of total employment) of Industry and Employment (as % of total employment) of Services?
Provide a short and direct response. -36.86. In the year 1999, what is the difference between the Employment (as % of total employment) of Industry and Employment (as % of total employment) of Self-employed?
Your answer should be very brief. -18.98. In the year 1999, what is the difference between the Employment (as % of total employment) in Services and Employment (as % of total employment) in Self-employed?
Offer a very short reply. 17.88. What is the ratio of the Employment (as % of total employment) in Agriculture in 1992 to that in 1993?
Give a very brief answer. 1.02. What is the ratio of the Employment (as % of total employment) in Services in 1992 to that in 1993?
Provide a short and direct response. 0.99. What is the ratio of the Employment (as % of total employment) in Self-employed in 1992 to that in 1993?
Keep it short and to the point. 1.01. What is the ratio of the Employment (as % of total employment) in Agriculture in 1992 to that in 1995?
Your response must be concise. 1.07. What is the ratio of the Employment (as % of total employment) in Industry in 1992 to that in 1995?
Provide a short and direct response. 1.03. What is the ratio of the Employment (as % of total employment) of Services in 1992 to that in 1995?
Offer a terse response. 0.96. What is the ratio of the Employment (as % of total employment) of Self-employed in 1992 to that in 1995?
Offer a terse response. 1.02. What is the ratio of the Employment (as % of total employment) of Agriculture in 1992 to that in 1996?
Provide a succinct answer. 1.13. What is the ratio of the Employment (as % of total employment) in Industry in 1992 to that in 1996?
Make the answer very short. 1.03. What is the ratio of the Employment (as % of total employment) of Services in 1992 to that in 1996?
Make the answer very short. 0.95. What is the ratio of the Employment (as % of total employment) in Self-employed in 1992 to that in 1996?
Give a very brief answer. 1.03. What is the ratio of the Employment (as % of total employment) of Agriculture in 1992 to that in 1997?
Your response must be concise. 1.11. What is the ratio of the Employment (as % of total employment) in Industry in 1992 to that in 1997?
Keep it short and to the point. 1.04. What is the ratio of the Employment (as % of total employment) in Services in 1992 to that in 1997?
Offer a terse response. 0.95. What is the ratio of the Employment (as % of total employment) in Self-employed in 1992 to that in 1997?
Your response must be concise. 1.1. What is the ratio of the Employment (as % of total employment) in Agriculture in 1992 to that in 1998?
Your answer should be compact. 1.17. What is the ratio of the Employment (as % of total employment) of Industry in 1992 to that in 1998?
Ensure brevity in your answer.  1.03. What is the ratio of the Employment (as % of total employment) in Services in 1992 to that in 1998?
Your answer should be very brief. 0.94. What is the ratio of the Employment (as % of total employment) of Self-employed in 1992 to that in 1998?
Give a very brief answer. 0.99. What is the ratio of the Employment (as % of total employment) of Agriculture in 1992 to that in 1999?
Your answer should be compact. 1.1. What is the ratio of the Employment (as % of total employment) in Industry in 1992 to that in 1999?
Make the answer very short. 1.07. What is the ratio of the Employment (as % of total employment) of Services in 1992 to that in 1999?
Keep it short and to the point. 0.94. What is the ratio of the Employment (as % of total employment) in Agriculture in 1993 to that in 1995?
Give a very brief answer. 1.05. What is the ratio of the Employment (as % of total employment) of Industry in 1993 to that in 1995?
Give a very brief answer. 1.03. What is the ratio of the Employment (as % of total employment) of Services in 1993 to that in 1995?
Your response must be concise. 0.97. What is the ratio of the Employment (as % of total employment) in Self-employed in 1993 to that in 1995?
Your response must be concise. 1.01. What is the ratio of the Employment (as % of total employment) in Agriculture in 1993 to that in 1996?
Your response must be concise. 1.1. What is the ratio of the Employment (as % of total employment) of Industry in 1993 to that in 1996?
Offer a very short reply. 1.03. What is the ratio of the Employment (as % of total employment) in Services in 1993 to that in 1996?
Provide a short and direct response. 0.95. What is the ratio of the Employment (as % of total employment) of Self-employed in 1993 to that in 1996?
Keep it short and to the point. 1.02. What is the ratio of the Employment (as % of total employment) in Agriculture in 1993 to that in 1997?
Ensure brevity in your answer.  1.08. What is the ratio of the Employment (as % of total employment) of Industry in 1993 to that in 1997?
Provide a short and direct response. 1.04. What is the ratio of the Employment (as % of total employment) of Services in 1993 to that in 1997?
Offer a very short reply. 0.95. What is the ratio of the Employment (as % of total employment) in Self-employed in 1993 to that in 1997?
Your answer should be compact. 1.09. What is the ratio of the Employment (as % of total employment) in Agriculture in 1993 to that in 1998?
Offer a very short reply. 1.14. What is the ratio of the Employment (as % of total employment) in Industry in 1993 to that in 1998?
Provide a short and direct response. 1.03. What is the ratio of the Employment (as % of total employment) in Services in 1993 to that in 1998?
Your response must be concise. 0.94. What is the ratio of the Employment (as % of total employment) in Self-employed in 1993 to that in 1998?
Make the answer very short. 0.98. What is the ratio of the Employment (as % of total employment) in Agriculture in 1993 to that in 1999?
Provide a short and direct response. 1.07. What is the ratio of the Employment (as % of total employment) in Industry in 1993 to that in 1999?
Offer a terse response. 1.06. What is the ratio of the Employment (as % of total employment) in Services in 1993 to that in 1999?
Give a very brief answer. 0.95. What is the ratio of the Employment (as % of total employment) in Agriculture in 1995 to that in 1996?
Your answer should be compact. 1.05. What is the ratio of the Employment (as % of total employment) in Industry in 1995 to that in 1996?
Provide a short and direct response. 1. What is the ratio of the Employment (as % of total employment) in Services in 1995 to that in 1996?
Make the answer very short. 0.98. What is the ratio of the Employment (as % of total employment) of Self-employed in 1995 to that in 1996?
Your answer should be compact. 1.01. What is the ratio of the Employment (as % of total employment) in Agriculture in 1995 to that in 1997?
Offer a very short reply. 1.03. What is the ratio of the Employment (as % of total employment) in Industry in 1995 to that in 1997?
Offer a terse response. 1.01. What is the ratio of the Employment (as % of total employment) in Services in 1995 to that in 1997?
Your answer should be compact. 0.99. What is the ratio of the Employment (as % of total employment) of Self-employed in 1995 to that in 1997?
Provide a succinct answer. 1.08. What is the ratio of the Employment (as % of total employment) in Agriculture in 1995 to that in 1998?
Offer a terse response. 1.09. What is the ratio of the Employment (as % of total employment) of Services in 1995 to that in 1998?
Offer a terse response. 0.97. What is the ratio of the Employment (as % of total employment) in Self-employed in 1995 to that in 1998?
Ensure brevity in your answer.  0.97. What is the ratio of the Employment (as % of total employment) of Agriculture in 1995 to that in 1999?
Give a very brief answer. 1.02. What is the ratio of the Employment (as % of total employment) in Industry in 1995 to that in 1999?
Give a very brief answer. 1.03. What is the ratio of the Employment (as % of total employment) of Services in 1995 to that in 1999?
Offer a terse response. 0.98. What is the ratio of the Employment (as % of total employment) in Self-employed in 1995 to that in 1999?
Keep it short and to the point. 0.98. What is the ratio of the Employment (as % of total employment) of Agriculture in 1996 to that in 1997?
Give a very brief answer. 0.98. What is the ratio of the Employment (as % of total employment) of Industry in 1996 to that in 1997?
Your response must be concise. 1.01. What is the ratio of the Employment (as % of total employment) in Self-employed in 1996 to that in 1997?
Your response must be concise. 1.07. What is the ratio of the Employment (as % of total employment) in Agriculture in 1996 to that in 1998?
Your answer should be compact. 1.04. What is the ratio of the Employment (as % of total employment) in Services in 1996 to that in 1998?
Your response must be concise. 0.99. What is the ratio of the Employment (as % of total employment) in Self-employed in 1996 to that in 1998?
Provide a succinct answer. 0.96. What is the ratio of the Employment (as % of total employment) in Agriculture in 1996 to that in 1999?
Give a very brief answer. 0.97. What is the ratio of the Employment (as % of total employment) of Industry in 1996 to that in 1999?
Make the answer very short. 1.03. What is the ratio of the Employment (as % of total employment) of Self-employed in 1996 to that in 1999?
Your response must be concise. 0.97. What is the ratio of the Employment (as % of total employment) of Agriculture in 1997 to that in 1998?
Your answer should be compact. 1.05. What is the ratio of the Employment (as % of total employment) in Self-employed in 1997 to that in 1998?
Offer a terse response. 0.9. What is the ratio of the Employment (as % of total employment) in Agriculture in 1997 to that in 1999?
Make the answer very short. 0.99. What is the ratio of the Employment (as % of total employment) in Industry in 1997 to that in 1999?
Ensure brevity in your answer.  1.02. What is the ratio of the Employment (as % of total employment) of Self-employed in 1997 to that in 1999?
Provide a succinct answer. 0.91. What is the ratio of the Employment (as % of total employment) of Agriculture in 1998 to that in 1999?
Offer a terse response. 0.94. What is the ratio of the Employment (as % of total employment) of Industry in 1998 to that in 1999?
Provide a short and direct response. 1.04. What is the ratio of the Employment (as % of total employment) of Services in 1998 to that in 1999?
Your answer should be compact. 1.01. What is the ratio of the Employment (as % of total employment) in Self-employed in 1998 to that in 1999?
Offer a terse response. 1.01. What is the difference between the highest and the second highest Employment (as % of total employment) of Agriculture?
Your answer should be very brief. 0.54. What is the difference between the highest and the second highest Employment (as % of total employment) in Industry?
Offer a terse response. 0.04. What is the difference between the highest and the second highest Employment (as % of total employment) in Services?
Make the answer very short. 0.4. What is the difference between the highest and the second highest Employment (as % of total employment) of Self-employed?
Keep it short and to the point. 0.45. What is the difference between the highest and the lowest Employment (as % of total employment) in Agriculture?
Keep it short and to the point. 3.19. What is the difference between the highest and the lowest Employment (as % of total employment) in Industry?
Ensure brevity in your answer.  1.41. What is the difference between the highest and the lowest Employment (as % of total employment) in Services?
Offer a terse response. 3.71. What is the difference between the highest and the lowest Employment (as % of total employment) of Self-employed?
Your response must be concise. 4.24. 